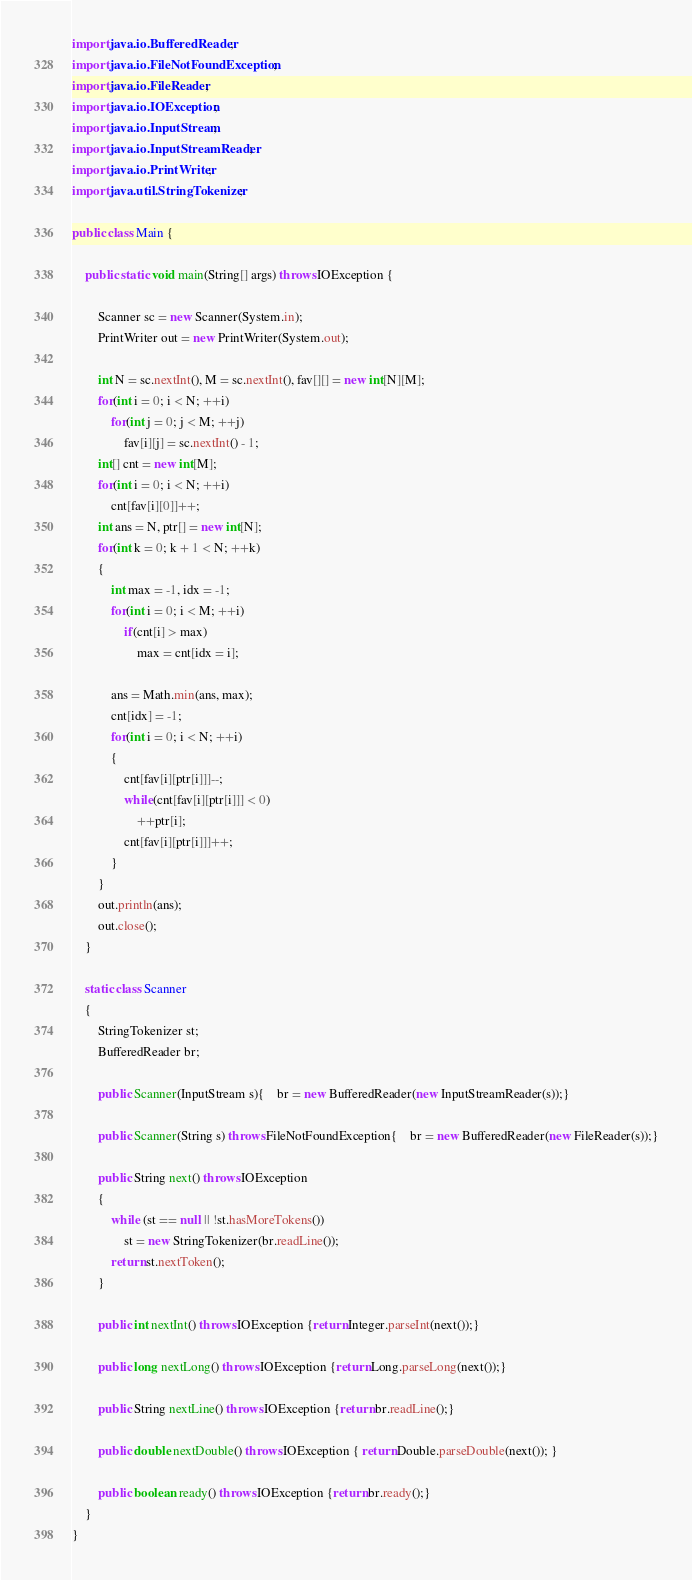Convert code to text. <code><loc_0><loc_0><loc_500><loc_500><_Java_>import java.io.BufferedReader;
import java.io.FileNotFoundException;
import java.io.FileReader;
import java.io.IOException;
import java.io.InputStream;
import java.io.InputStreamReader;
import java.io.PrintWriter;
import java.util.StringTokenizer;

public class Main {
	
	public static void main(String[] args) throws IOException {

		Scanner sc = new Scanner(System.in);
		PrintWriter out = new PrintWriter(System.out);

		int N = sc.nextInt(), M = sc.nextInt(), fav[][] = new int[N][M];
		for(int i = 0; i < N; ++i)
			for(int j = 0; j < M; ++j)
				fav[i][j] = sc.nextInt() - 1;
		int[] cnt = new int[M];
		for(int i = 0; i < N; ++i)
			cnt[fav[i][0]]++;
		int ans = N, ptr[] = new int[N];
		for(int k = 0; k + 1 < N; ++k)
		{
			int max = -1, idx = -1;
			for(int i = 0; i < M; ++i)
				if(cnt[i] > max)
					max = cnt[idx = i];

			ans = Math.min(ans, max);
			cnt[idx] = -1;
			for(int i = 0; i < N; ++i)
			{	
				cnt[fav[i][ptr[i]]]--;
				while(cnt[fav[i][ptr[i]]] < 0)
					++ptr[i];
				cnt[fav[i][ptr[i]]]++;
			}
		}
		out.println(ans);
		out.close();
	}

	static class Scanner 
	{
		StringTokenizer st;
		BufferedReader br;

		public Scanner(InputStream s){	br = new BufferedReader(new InputStreamReader(s));}

		public Scanner(String s) throws FileNotFoundException{	br = new BufferedReader(new FileReader(s));}

		public String next() throws IOException 
		{
			while (st == null || !st.hasMoreTokens()) 
				st = new StringTokenizer(br.readLine());
			return st.nextToken();
		}

		public int nextInt() throws IOException {return Integer.parseInt(next());}

		public long nextLong() throws IOException {return Long.parseLong(next());}

		public String nextLine() throws IOException {return br.readLine();}

		public double nextDouble() throws IOException { return Double.parseDouble(next()); }

		public boolean ready() throws IOException {return br.ready();} 
	}
}</code> 